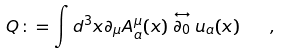<formula> <loc_0><loc_0><loc_500><loc_500>Q \colon = \int d ^ { 3 } x \partial _ { \mu } A _ { a } ^ { \mu } ( x ) \stackrel { \leftrightarrow } { \partial _ { 0 } } u _ { a } ( x ) \quad ,</formula> 